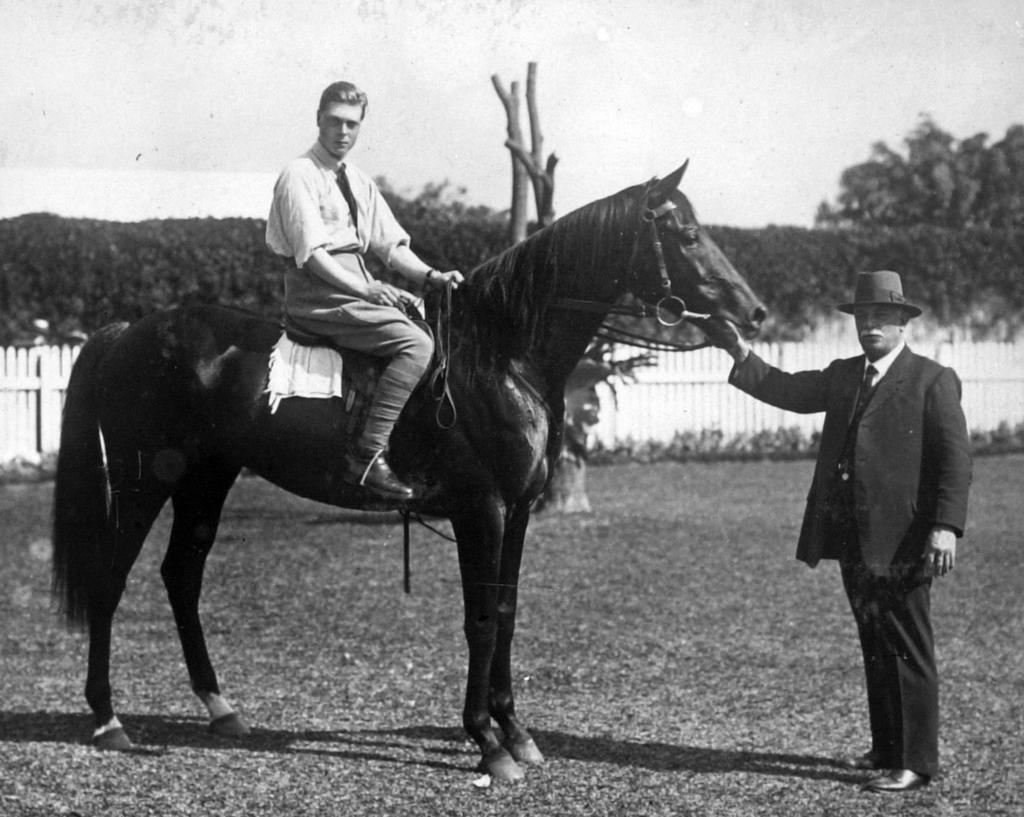Could you give a brief overview of what you see in this image? In this picture we can see two persons and a Horse, one man is seated on the horse and another man is holding the horse, in the background we can see fence and a couple of trees. 